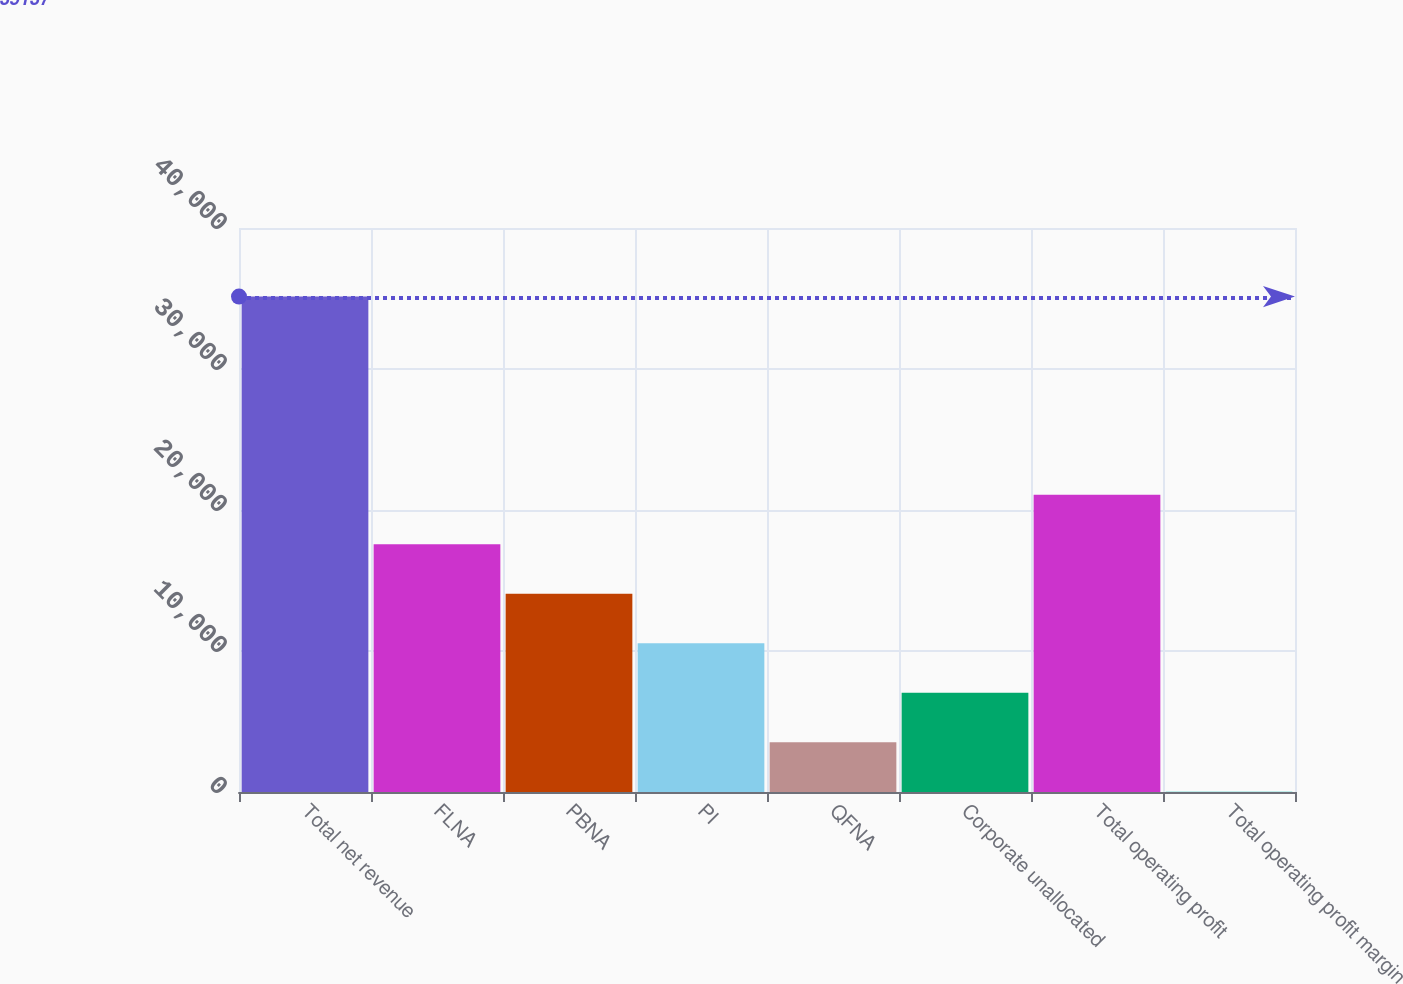<chart> <loc_0><loc_0><loc_500><loc_500><bar_chart><fcel>Total net revenue<fcel>FLNA<fcel>PBNA<fcel>PI<fcel>QFNA<fcel>Corporate unallocated<fcel>Total operating profit<fcel>Total operating profit margin<nl><fcel>35137<fcel>17577.8<fcel>14065.9<fcel>10554<fcel>3530.35<fcel>7042.2<fcel>21089.6<fcel>18.5<nl></chart> 